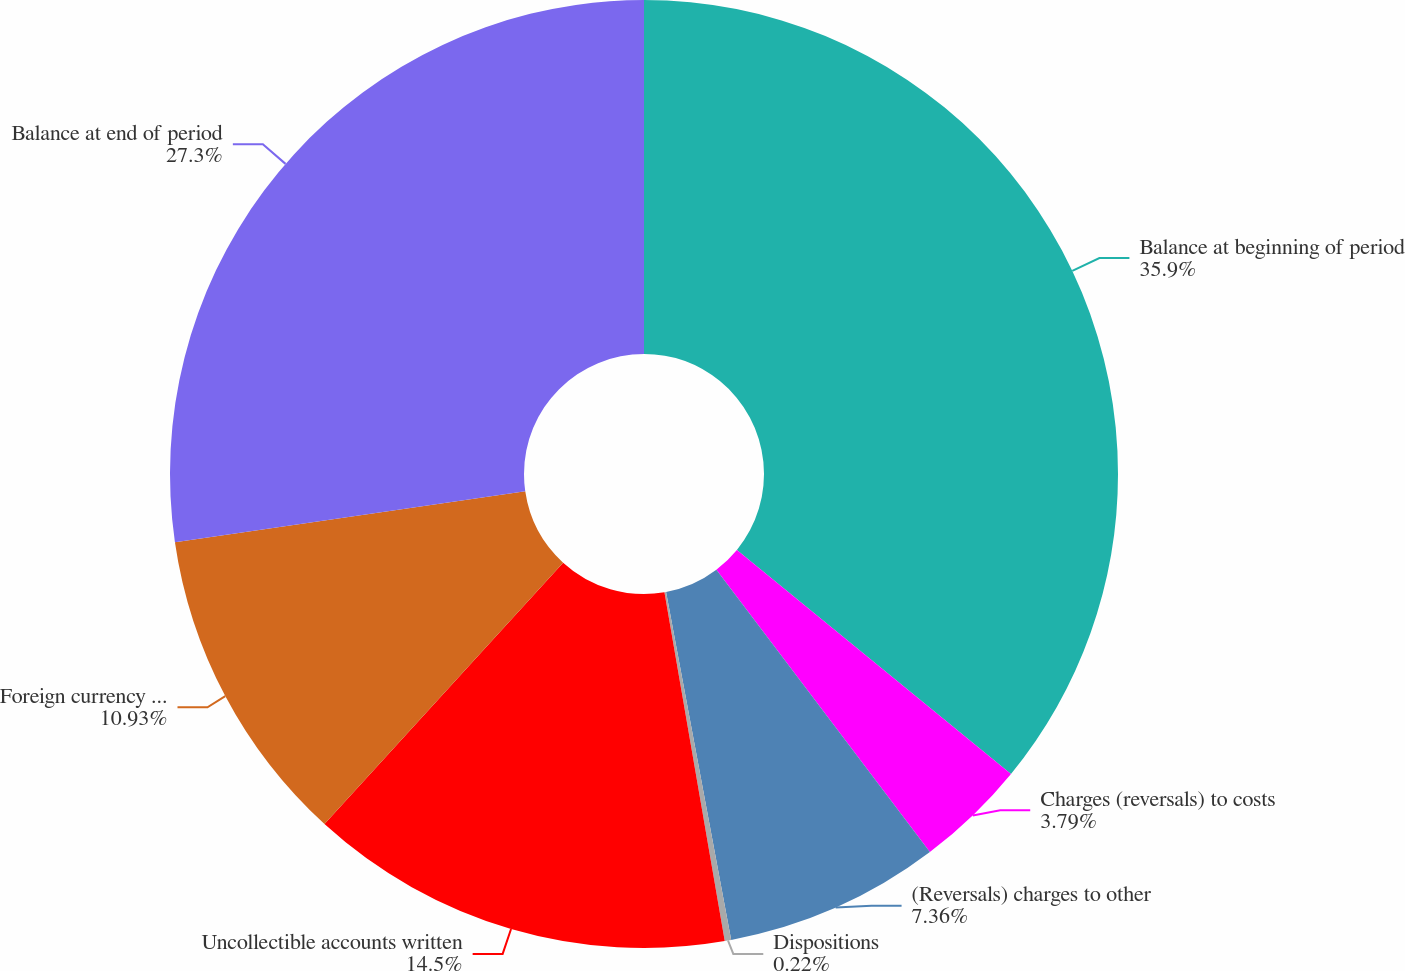Convert chart. <chart><loc_0><loc_0><loc_500><loc_500><pie_chart><fcel>Balance at beginning of period<fcel>Charges (reversals) to costs<fcel>(Reversals) charges to other<fcel>Dispositions<fcel>Uncollectible accounts written<fcel>Foreign currency translation<fcel>Balance at end of period<nl><fcel>35.91%<fcel>3.79%<fcel>7.36%<fcel>0.22%<fcel>14.5%<fcel>10.93%<fcel>27.3%<nl></chart> 